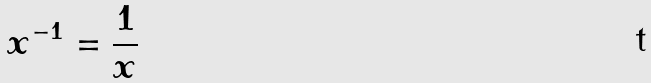Convert formula to latex. <formula><loc_0><loc_0><loc_500><loc_500>x ^ { - 1 } = \frac { 1 } { x }</formula> 